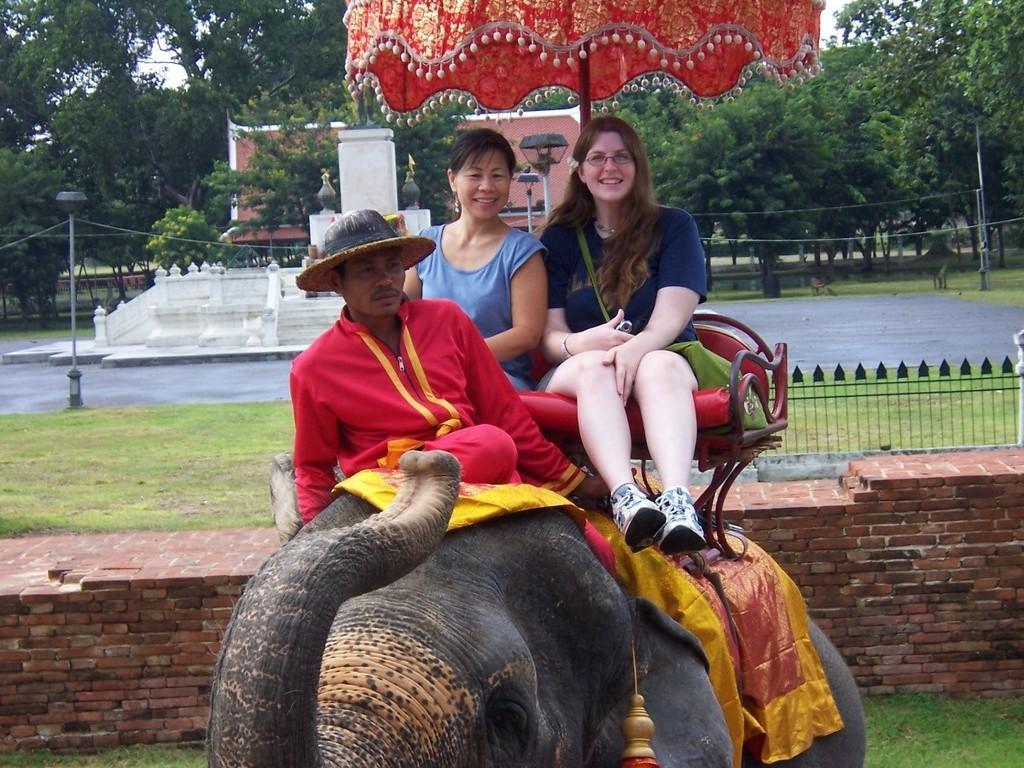Please provide a concise description of this image. In this image there are three persons. A Mahout who is riding the elephant and two persons sitting on the elephant and at the background of the image there are trees. 